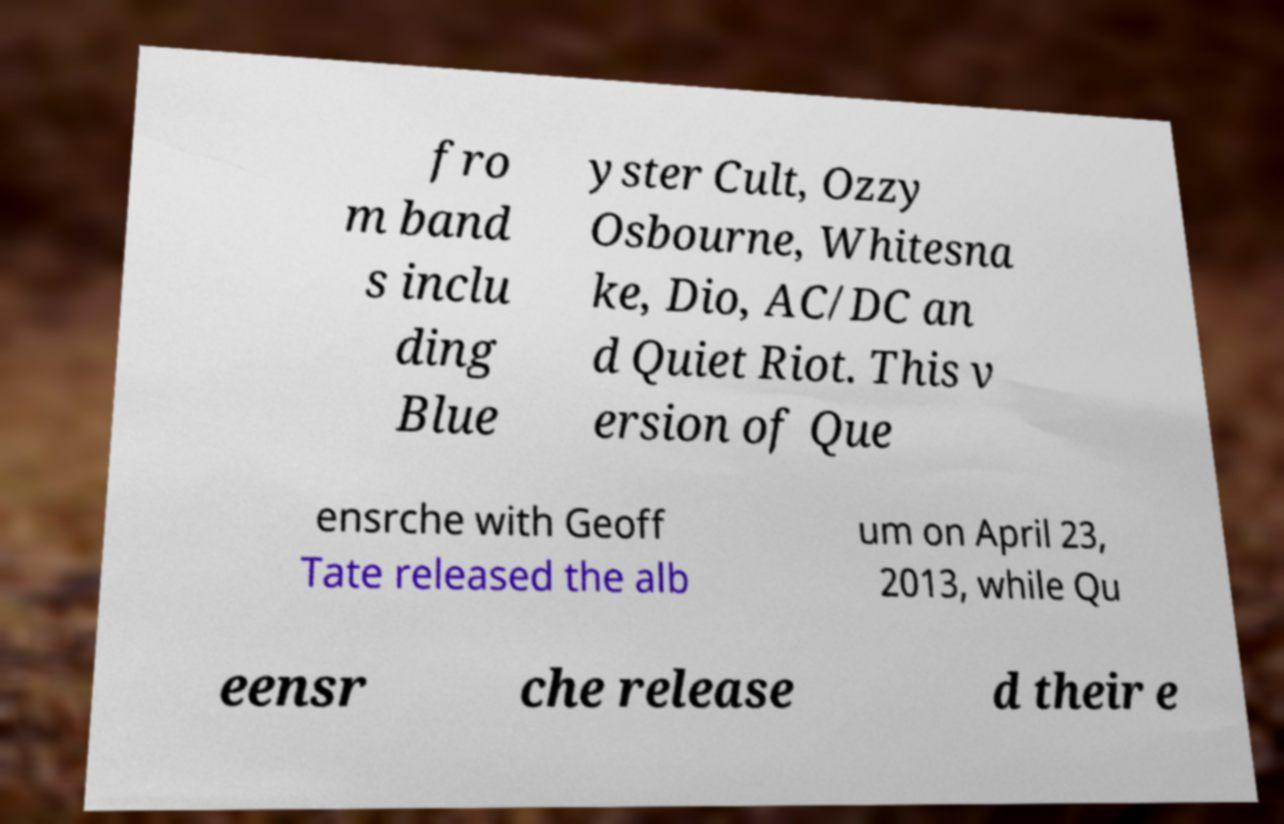Can you read and provide the text displayed in the image?This photo seems to have some interesting text. Can you extract and type it out for me? fro m band s inclu ding Blue yster Cult, Ozzy Osbourne, Whitesna ke, Dio, AC/DC an d Quiet Riot. This v ersion of Que ensrche with Geoff Tate released the alb um on April 23, 2013, while Qu eensr che release d their e 